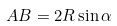Convert formula to latex. <formula><loc_0><loc_0><loc_500><loc_500>A B = 2 R \sin \alpha</formula> 